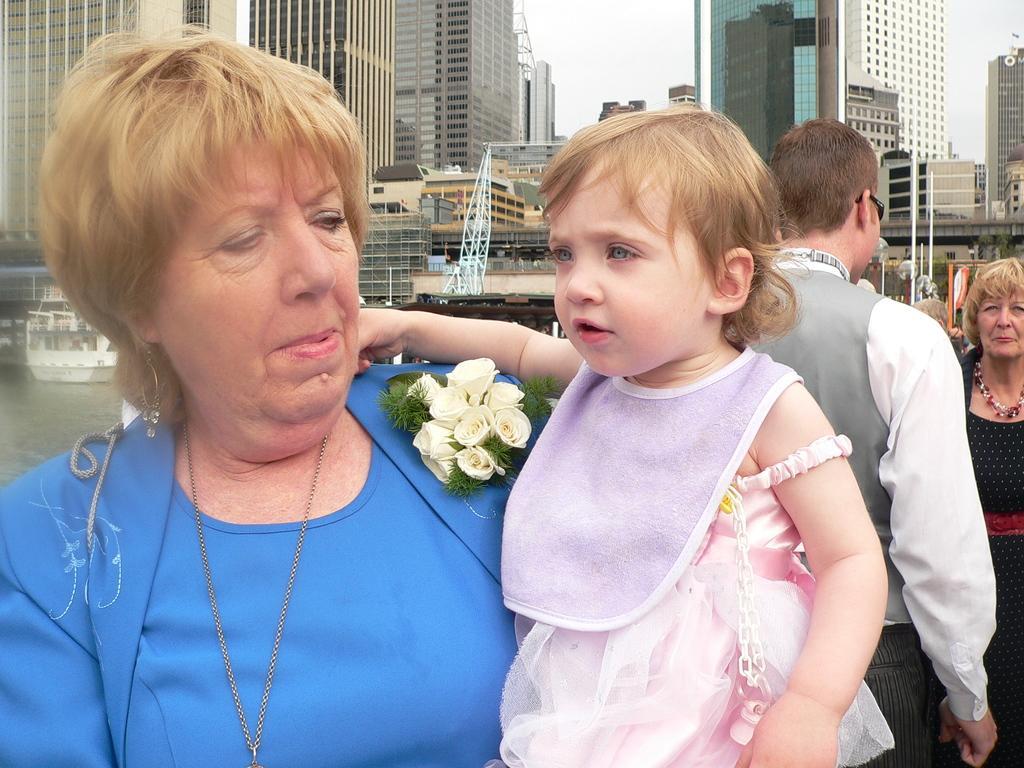Describe this image in one or two sentences. As we can see in the image there are few people here and there, flowers, water, boat, buildings and sky. 